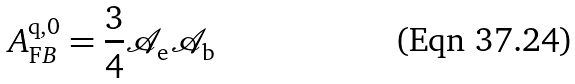Convert formula to latex. <formula><loc_0><loc_0><loc_500><loc_500>A _ { \mathrm F B } ^ { \mathrm q , 0 } = \frac { 3 } { 4 } { \mathcal { A } } _ { \mathrm e } { \mathcal { A } } _ { \mathrm b }</formula> 